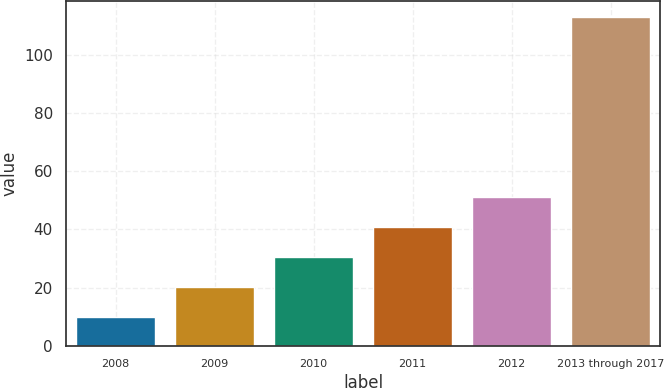Convert chart to OTSL. <chart><loc_0><loc_0><loc_500><loc_500><bar_chart><fcel>2008<fcel>2009<fcel>2010<fcel>2011<fcel>2012<fcel>2013 through 2017<nl><fcel>10<fcel>20.3<fcel>30.6<fcel>40.9<fcel>51.2<fcel>113<nl></chart> 